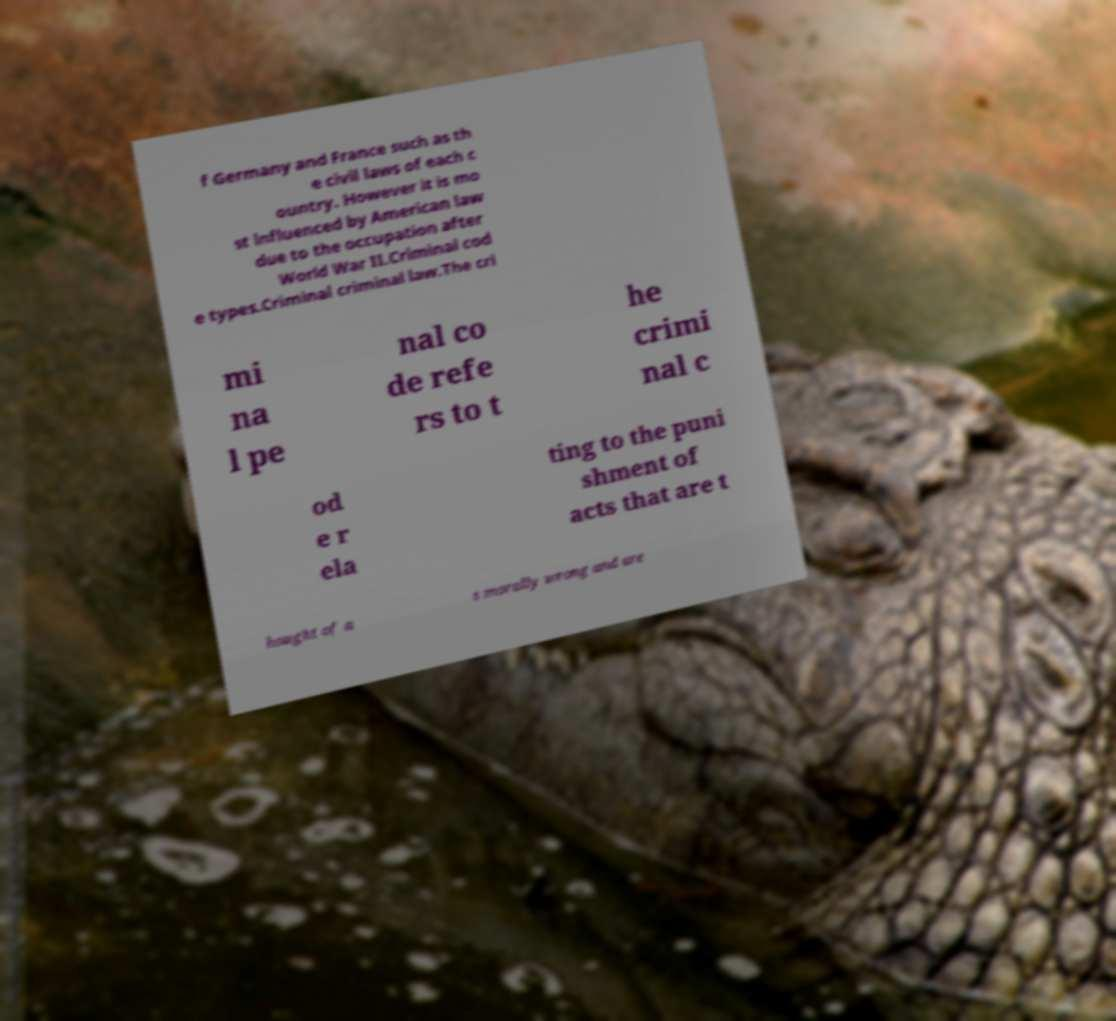Can you read and provide the text displayed in the image?This photo seems to have some interesting text. Can you extract and type it out for me? f Germany and France such as th e civil laws of each c ountry. However it is mo st influenced by American law due to the occupation after World War II.Criminal cod e types.Criminal criminal law.The cri mi na l pe nal co de refe rs to t he crimi nal c od e r ela ting to the puni shment of acts that are t hought of a s morally wrong and are 